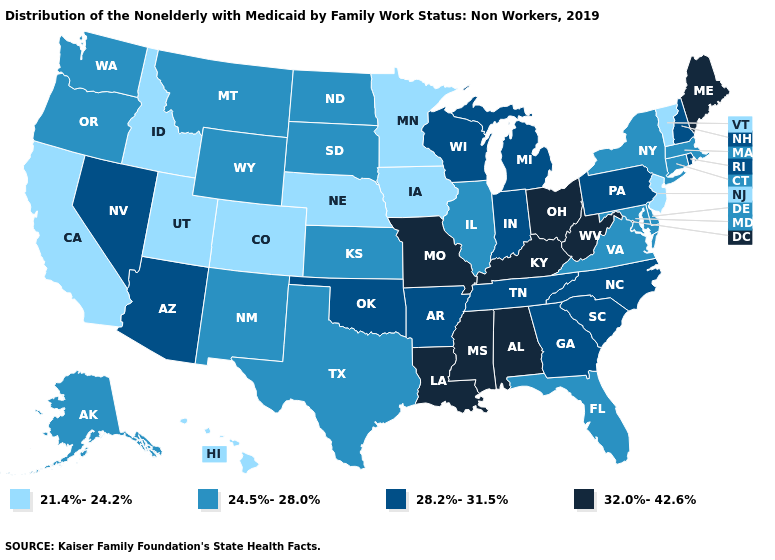Name the states that have a value in the range 28.2%-31.5%?
Quick response, please. Arizona, Arkansas, Georgia, Indiana, Michigan, Nevada, New Hampshire, North Carolina, Oklahoma, Pennsylvania, Rhode Island, South Carolina, Tennessee, Wisconsin. Name the states that have a value in the range 24.5%-28.0%?
Short answer required. Alaska, Connecticut, Delaware, Florida, Illinois, Kansas, Maryland, Massachusetts, Montana, New Mexico, New York, North Dakota, Oregon, South Dakota, Texas, Virginia, Washington, Wyoming. Name the states that have a value in the range 21.4%-24.2%?
Write a very short answer. California, Colorado, Hawaii, Idaho, Iowa, Minnesota, Nebraska, New Jersey, Utah, Vermont. What is the lowest value in the Northeast?
Concise answer only. 21.4%-24.2%. Does Idaho have the lowest value in the USA?
Concise answer only. Yes. Does Kentucky have the highest value in the USA?
Answer briefly. Yes. What is the value of Georgia?
Give a very brief answer. 28.2%-31.5%. Name the states that have a value in the range 28.2%-31.5%?
Be succinct. Arizona, Arkansas, Georgia, Indiana, Michigan, Nevada, New Hampshire, North Carolina, Oklahoma, Pennsylvania, Rhode Island, South Carolina, Tennessee, Wisconsin. Name the states that have a value in the range 24.5%-28.0%?
Write a very short answer. Alaska, Connecticut, Delaware, Florida, Illinois, Kansas, Maryland, Massachusetts, Montana, New Mexico, New York, North Dakota, Oregon, South Dakota, Texas, Virginia, Washington, Wyoming. Does Georgia have the lowest value in the USA?
Write a very short answer. No. Does West Virginia have the highest value in the USA?
Write a very short answer. Yes. What is the value of Pennsylvania?
Quick response, please. 28.2%-31.5%. Among the states that border Tennessee , which have the highest value?
Short answer required. Alabama, Kentucky, Mississippi, Missouri. Does the first symbol in the legend represent the smallest category?
Give a very brief answer. Yes. Which states hav the highest value in the MidWest?
Give a very brief answer. Missouri, Ohio. 